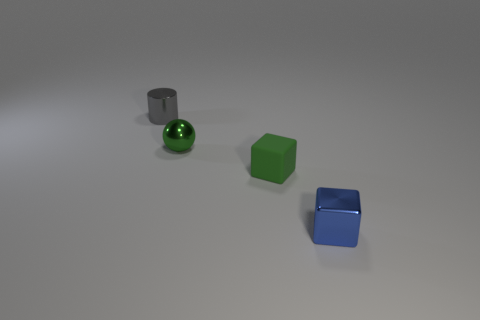Add 1 tiny green things. How many objects exist? 5 Subtract all cylinders. How many objects are left? 3 Subtract all yellow rubber objects. Subtract all spheres. How many objects are left? 3 Add 2 tiny gray things. How many tiny gray things are left? 3 Add 1 green spheres. How many green spheres exist? 2 Subtract 0 yellow cubes. How many objects are left? 4 